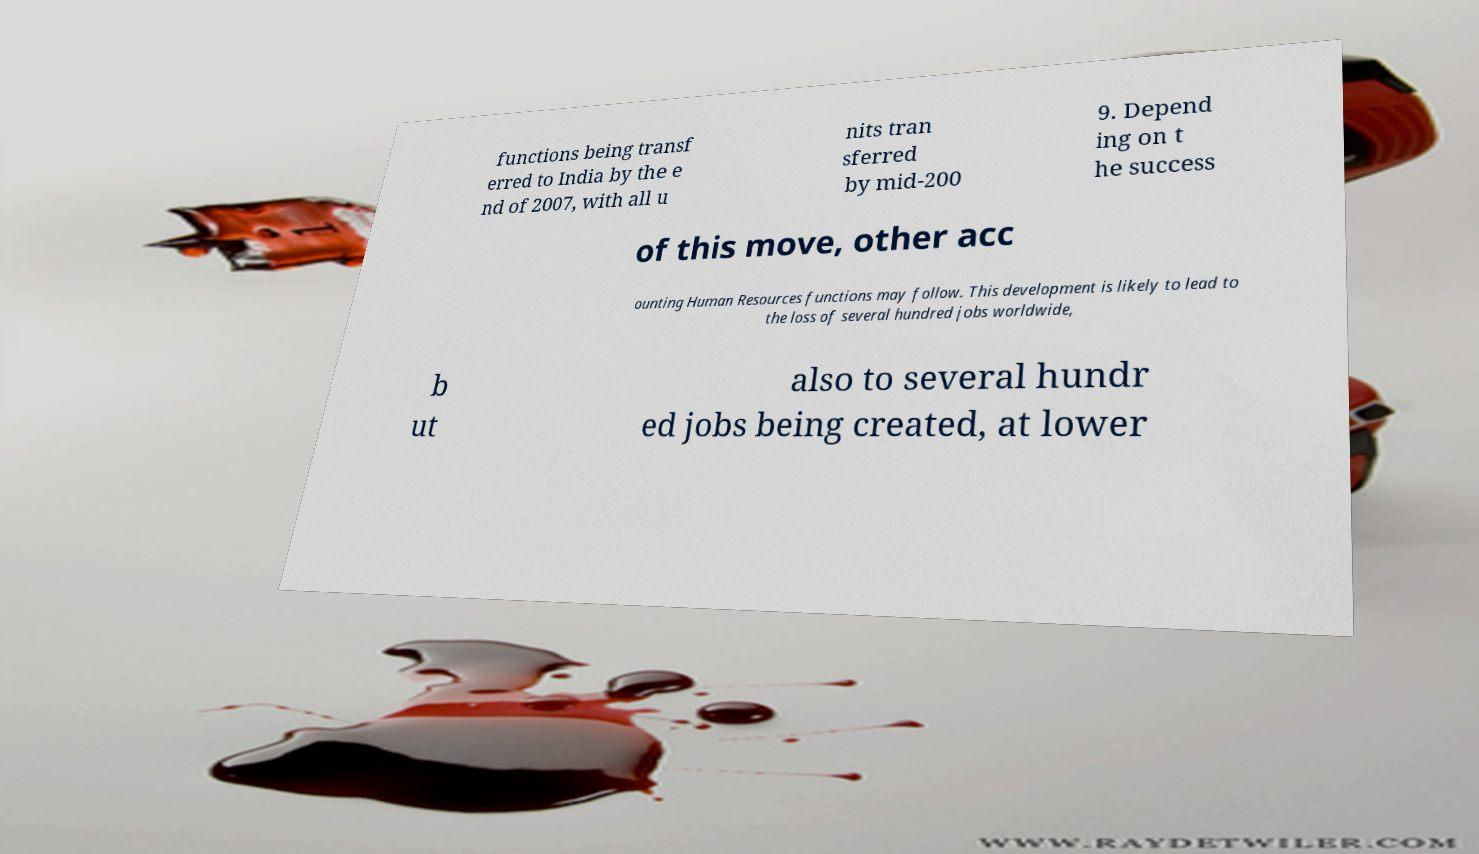Please identify and transcribe the text found in this image. functions being transf erred to India by the e nd of 2007, with all u nits tran sferred by mid-200 9. Depend ing on t he success of this move, other acc ounting Human Resources functions may follow. This development is likely to lead to the loss of several hundred jobs worldwide, b ut also to several hundr ed jobs being created, at lower 